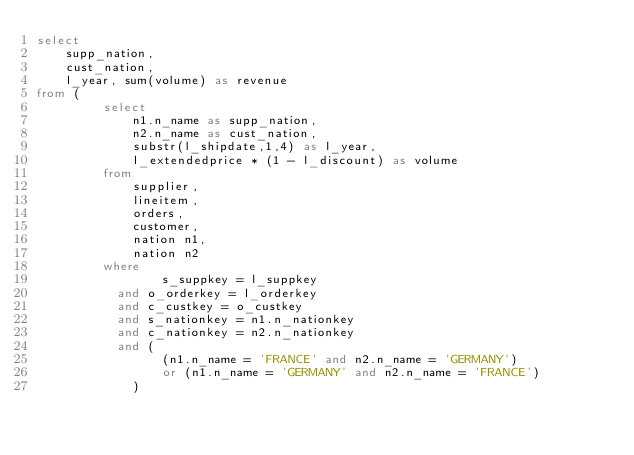Convert code to text. <code><loc_0><loc_0><loc_500><loc_500><_SQL_>select
    supp_nation,
    cust_nation,
    l_year, sum(volume) as revenue
from (
         select
             n1.n_name as supp_nation,
             n2.n_name as cust_nation,
             substr(l_shipdate,1,4) as l_year,
             l_extendedprice * (1 - l_discount) as volume
         from
             supplier,
             lineitem,
             orders,
             customer,
             nation n1,
             nation n2
         where
                 s_suppkey = l_suppkey
           and o_orderkey = l_orderkey
           and c_custkey = o_custkey
           and s_nationkey = n1.n_nationkey
           and c_nationkey = n2.n_nationkey
           and (
                 (n1.n_name = 'FRANCE' and n2.n_name = 'GERMANY')
                 or (n1.n_name = 'GERMANY' and n2.n_name = 'FRANCE')
             )</code> 